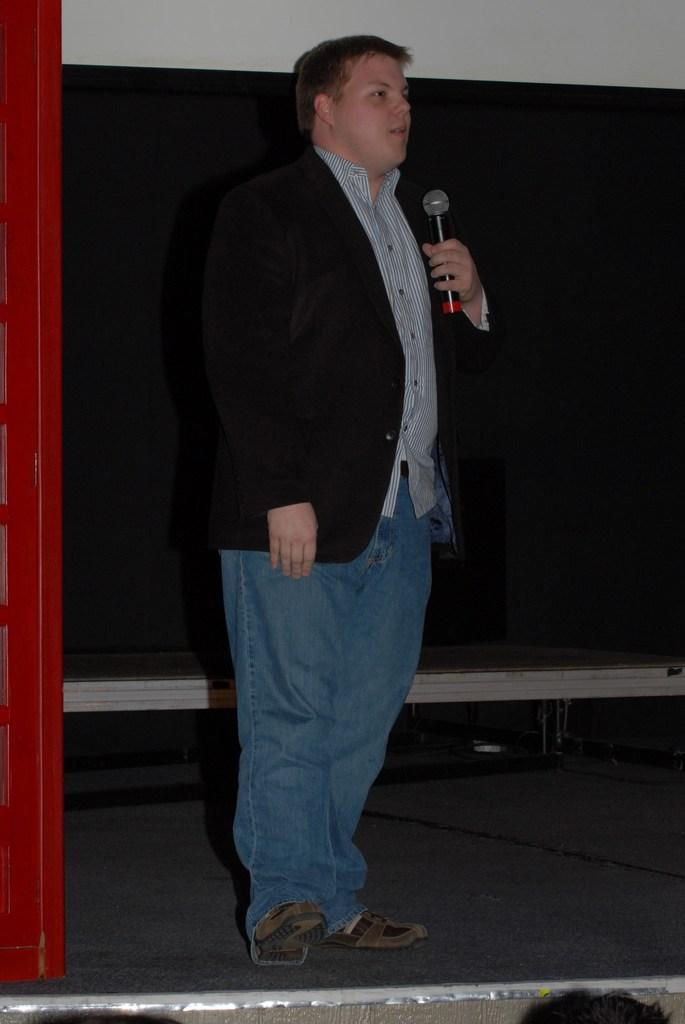Describe this image in one or two sentences. In this image I see a man standing and he is holding a mic. 